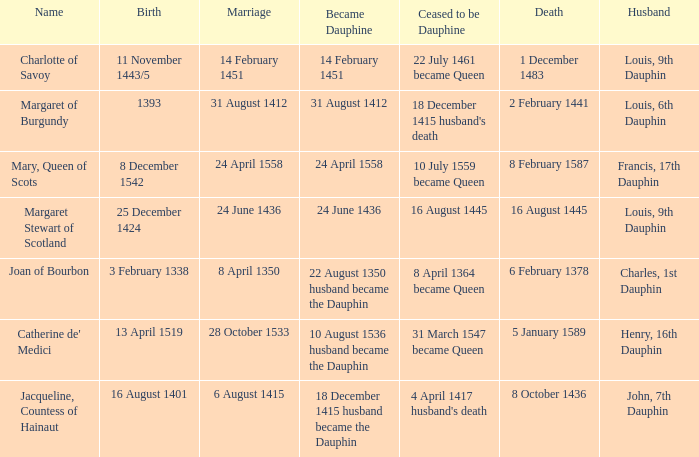Who has a birth of 16 august 1401? Jacqueline, Countess of Hainaut. Would you mind parsing the complete table? {'header': ['Name', 'Birth', 'Marriage', 'Became Dauphine', 'Ceased to be Dauphine', 'Death', 'Husband'], 'rows': [['Charlotte of Savoy', '11 November 1443/5', '14 February 1451', '14 February 1451', '22 July 1461 became Queen', '1 December 1483', 'Louis, 9th Dauphin'], ['Margaret of Burgundy', '1393', '31 August 1412', '31 August 1412', "18 December 1415 husband's death", '2 February 1441', 'Louis, 6th Dauphin'], ['Mary, Queen of Scots', '8 December 1542', '24 April 1558', '24 April 1558', '10 July 1559 became Queen', '8 February 1587', 'Francis, 17th Dauphin'], ['Margaret Stewart of Scotland', '25 December 1424', '24 June 1436', '24 June 1436', '16 August 1445', '16 August 1445', 'Louis, 9th Dauphin'], ['Joan of Bourbon', '3 February 1338', '8 April 1350', '22 August 1350 husband became the Dauphin', '8 April 1364 became Queen', '6 February 1378', 'Charles, 1st Dauphin'], ["Catherine de' Medici", '13 April 1519', '28 October 1533', '10 August 1536 husband became the Dauphin', '31 March 1547 became Queen', '5 January 1589', 'Henry, 16th Dauphin'], ['Jacqueline, Countess of Hainaut', '16 August 1401', '6 August 1415', '18 December 1415 husband became the Dauphin', "4 April 1417 husband's death", '8 October 1436', 'John, 7th Dauphin']]} 